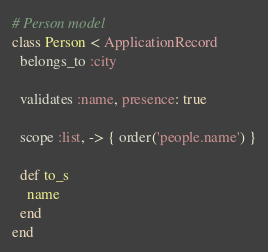Convert code to text. <code><loc_0><loc_0><loc_500><loc_500><_Ruby_># Person model
class Person < ApplicationRecord
  belongs_to :city

  validates :name, presence: true

  scope :list, -> { order('people.name') }

  def to_s
    name
  end
end
</code> 